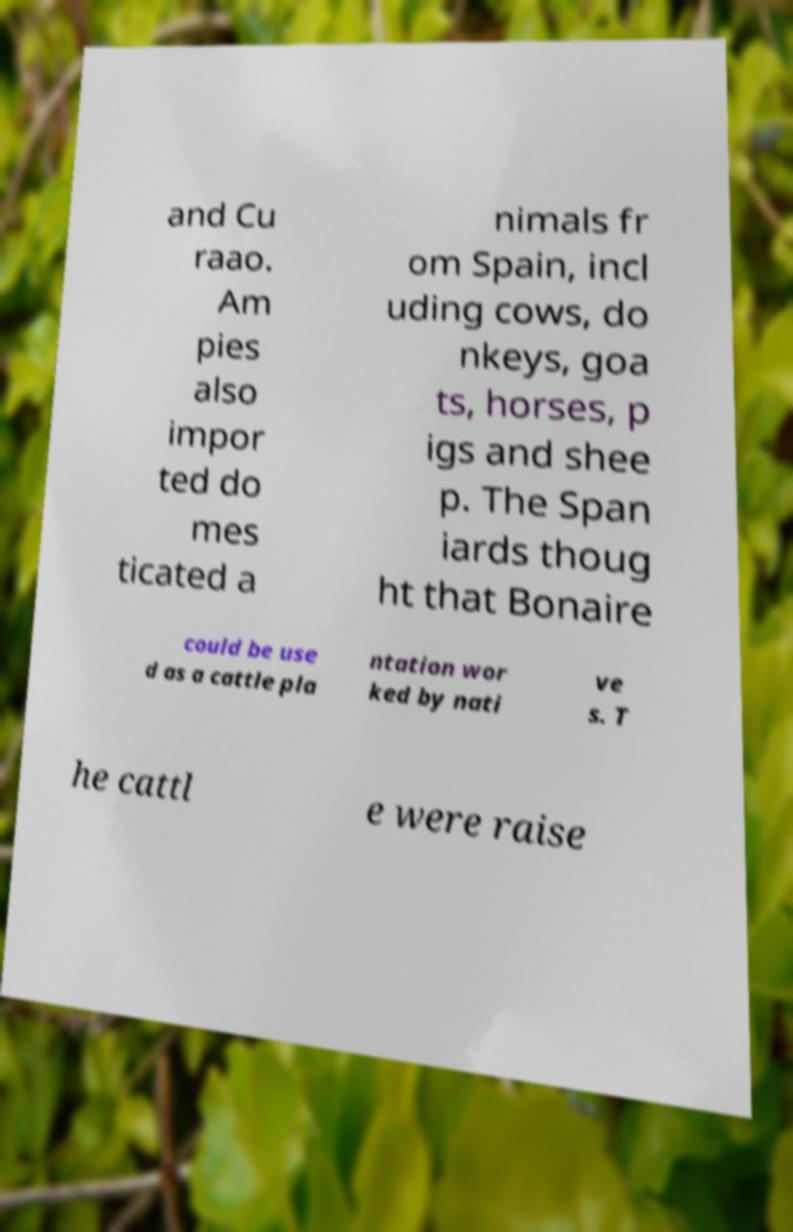Please identify and transcribe the text found in this image. and Cu raao. Am pies also impor ted do mes ticated a nimals fr om Spain, incl uding cows, do nkeys, goa ts, horses, p igs and shee p. The Span iards thoug ht that Bonaire could be use d as a cattle pla ntation wor ked by nati ve s. T he cattl e were raise 